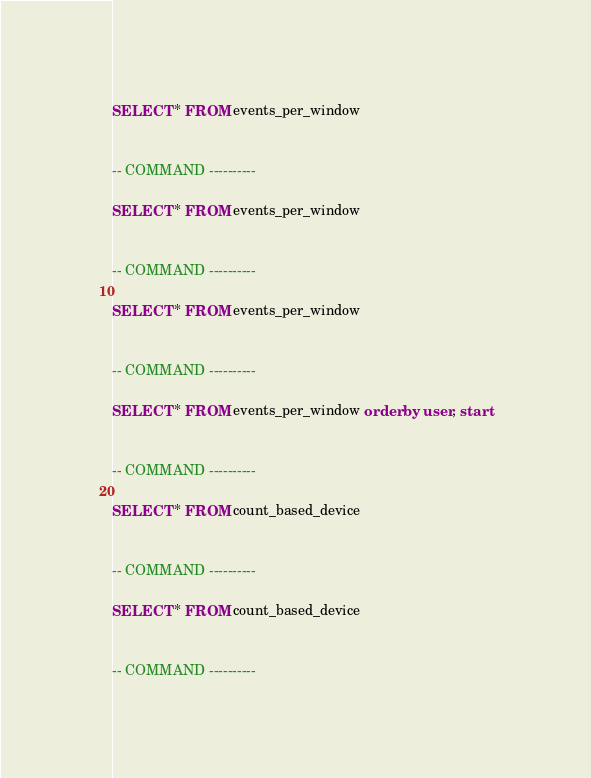<code> <loc_0><loc_0><loc_500><loc_500><_SQL_>SELECT * FROM events_per_window


-- COMMAND ----------

SELECT * FROM events_per_window


-- COMMAND ----------

SELECT * FROM events_per_window


-- COMMAND ----------

SELECT * FROM events_per_window order by user, start


-- COMMAND ----------

SELECT * FROM count_based_device


-- COMMAND ----------

SELECT * FROM count_based_device


-- COMMAND ----------

</code> 